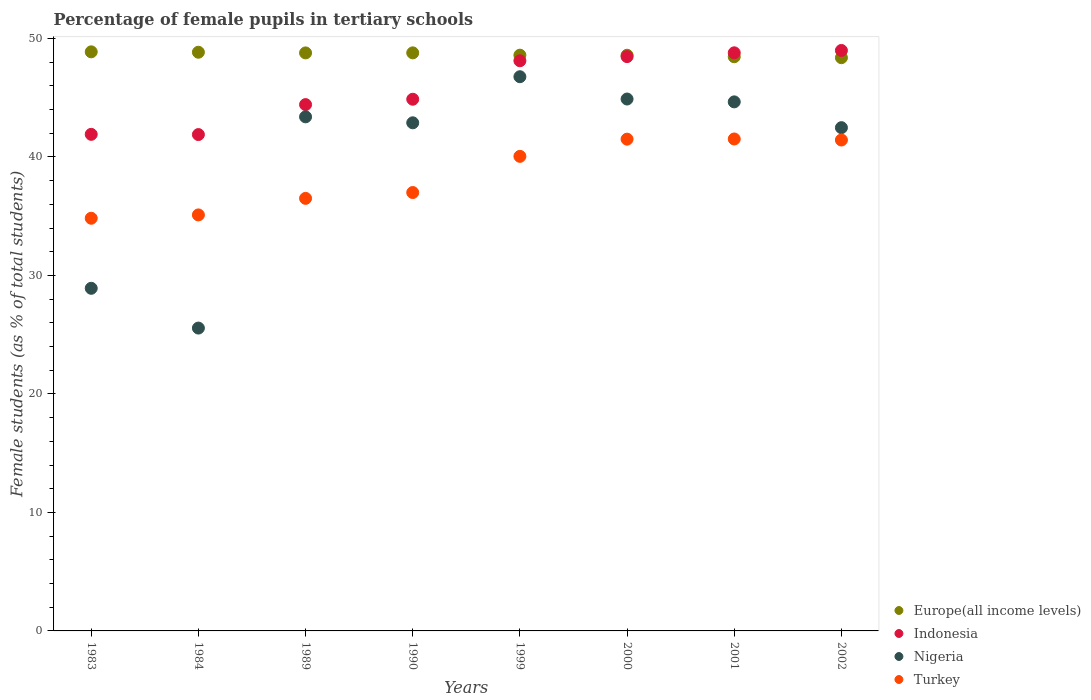How many different coloured dotlines are there?
Your answer should be compact. 4. Is the number of dotlines equal to the number of legend labels?
Ensure brevity in your answer.  Yes. What is the percentage of female pupils in tertiary schools in Turkey in 2001?
Provide a short and direct response. 41.51. Across all years, what is the maximum percentage of female pupils in tertiary schools in Turkey?
Make the answer very short. 41.51. Across all years, what is the minimum percentage of female pupils in tertiary schools in Nigeria?
Provide a short and direct response. 25.56. In which year was the percentage of female pupils in tertiary schools in Nigeria maximum?
Your answer should be very brief. 1999. What is the total percentage of female pupils in tertiary schools in Europe(all income levels) in the graph?
Provide a short and direct response. 389.24. What is the difference between the percentage of female pupils in tertiary schools in Turkey in 1984 and that in 1999?
Offer a very short reply. -4.94. What is the difference between the percentage of female pupils in tertiary schools in Europe(all income levels) in 1984 and the percentage of female pupils in tertiary schools in Turkey in 2000?
Provide a succinct answer. 7.33. What is the average percentage of female pupils in tertiary schools in Turkey per year?
Provide a succinct answer. 38.49. In the year 1999, what is the difference between the percentage of female pupils in tertiary schools in Indonesia and percentage of female pupils in tertiary schools in Turkey?
Offer a very short reply. 8.07. What is the ratio of the percentage of female pupils in tertiary schools in Turkey in 1984 to that in 2001?
Offer a very short reply. 0.85. What is the difference between the highest and the second highest percentage of female pupils in tertiary schools in Europe(all income levels)?
Your response must be concise. 0.03. What is the difference between the highest and the lowest percentage of female pupils in tertiary schools in Europe(all income levels)?
Give a very brief answer. 0.49. In how many years, is the percentage of female pupils in tertiary schools in Europe(all income levels) greater than the average percentage of female pupils in tertiary schools in Europe(all income levels) taken over all years?
Offer a very short reply. 4. Is it the case that in every year, the sum of the percentage of female pupils in tertiary schools in Turkey and percentage of female pupils in tertiary schools in Indonesia  is greater than the percentage of female pupils in tertiary schools in Nigeria?
Give a very brief answer. Yes. Does the percentage of female pupils in tertiary schools in Nigeria monotonically increase over the years?
Your answer should be very brief. No. Is the percentage of female pupils in tertiary schools in Nigeria strictly greater than the percentage of female pupils in tertiary schools in Europe(all income levels) over the years?
Provide a short and direct response. No. Is the percentage of female pupils in tertiary schools in Europe(all income levels) strictly less than the percentage of female pupils in tertiary schools in Nigeria over the years?
Provide a succinct answer. No. How many dotlines are there?
Your answer should be very brief. 4. Are the values on the major ticks of Y-axis written in scientific E-notation?
Make the answer very short. No. Does the graph contain grids?
Your response must be concise. No. How many legend labels are there?
Make the answer very short. 4. What is the title of the graph?
Keep it short and to the point. Percentage of female pupils in tertiary schools. Does "United Kingdom" appear as one of the legend labels in the graph?
Your response must be concise. No. What is the label or title of the X-axis?
Ensure brevity in your answer.  Years. What is the label or title of the Y-axis?
Provide a succinct answer. Female students (as % of total students). What is the Female students (as % of total students) in Europe(all income levels) in 1983?
Offer a terse response. 48.87. What is the Female students (as % of total students) in Indonesia in 1983?
Offer a very short reply. 41.9. What is the Female students (as % of total students) in Nigeria in 1983?
Offer a terse response. 28.91. What is the Female students (as % of total students) of Turkey in 1983?
Keep it short and to the point. 34.82. What is the Female students (as % of total students) of Europe(all income levels) in 1984?
Provide a short and direct response. 48.83. What is the Female students (as % of total students) in Indonesia in 1984?
Keep it short and to the point. 41.88. What is the Female students (as % of total students) of Nigeria in 1984?
Your response must be concise. 25.56. What is the Female students (as % of total students) in Turkey in 1984?
Provide a short and direct response. 35.1. What is the Female students (as % of total students) of Europe(all income levels) in 1989?
Provide a succinct answer. 48.78. What is the Female students (as % of total students) of Indonesia in 1989?
Provide a short and direct response. 44.41. What is the Female students (as % of total students) in Nigeria in 1989?
Keep it short and to the point. 43.38. What is the Female students (as % of total students) of Turkey in 1989?
Keep it short and to the point. 36.5. What is the Female students (as % of total students) of Europe(all income levels) in 1990?
Make the answer very short. 48.78. What is the Female students (as % of total students) in Indonesia in 1990?
Provide a succinct answer. 44.87. What is the Female students (as % of total students) of Nigeria in 1990?
Ensure brevity in your answer.  42.88. What is the Female students (as % of total students) in Turkey in 1990?
Offer a terse response. 36.99. What is the Female students (as % of total students) in Europe(all income levels) in 1999?
Give a very brief answer. 48.59. What is the Female students (as % of total students) in Indonesia in 1999?
Provide a succinct answer. 48.11. What is the Female students (as % of total students) in Nigeria in 1999?
Your response must be concise. 46.77. What is the Female students (as % of total students) of Turkey in 1999?
Your response must be concise. 40.05. What is the Female students (as % of total students) of Europe(all income levels) in 2000?
Keep it short and to the point. 48.58. What is the Female students (as % of total students) of Indonesia in 2000?
Your answer should be very brief. 48.46. What is the Female students (as % of total students) in Nigeria in 2000?
Provide a short and direct response. 44.88. What is the Female students (as % of total students) in Turkey in 2000?
Your answer should be very brief. 41.5. What is the Female students (as % of total students) in Europe(all income levels) in 2001?
Provide a short and direct response. 48.45. What is the Female students (as % of total students) of Indonesia in 2001?
Your answer should be compact. 48.78. What is the Female students (as % of total students) of Nigeria in 2001?
Your response must be concise. 44.64. What is the Female students (as % of total students) in Turkey in 2001?
Ensure brevity in your answer.  41.51. What is the Female students (as % of total students) in Europe(all income levels) in 2002?
Offer a very short reply. 48.37. What is the Female students (as % of total students) in Indonesia in 2002?
Provide a short and direct response. 48.98. What is the Female students (as % of total students) in Nigeria in 2002?
Offer a terse response. 42.47. What is the Female students (as % of total students) of Turkey in 2002?
Your response must be concise. 41.42. Across all years, what is the maximum Female students (as % of total students) in Europe(all income levels)?
Keep it short and to the point. 48.87. Across all years, what is the maximum Female students (as % of total students) in Indonesia?
Make the answer very short. 48.98. Across all years, what is the maximum Female students (as % of total students) in Nigeria?
Ensure brevity in your answer.  46.77. Across all years, what is the maximum Female students (as % of total students) of Turkey?
Provide a short and direct response. 41.51. Across all years, what is the minimum Female students (as % of total students) in Europe(all income levels)?
Offer a terse response. 48.37. Across all years, what is the minimum Female students (as % of total students) in Indonesia?
Provide a short and direct response. 41.88. Across all years, what is the minimum Female students (as % of total students) in Nigeria?
Your response must be concise. 25.56. Across all years, what is the minimum Female students (as % of total students) in Turkey?
Offer a terse response. 34.82. What is the total Female students (as % of total students) of Europe(all income levels) in the graph?
Give a very brief answer. 389.24. What is the total Female students (as % of total students) in Indonesia in the graph?
Your answer should be very brief. 367.41. What is the total Female students (as % of total students) of Nigeria in the graph?
Offer a terse response. 319.49. What is the total Female students (as % of total students) in Turkey in the graph?
Offer a terse response. 307.9. What is the difference between the Female students (as % of total students) in Europe(all income levels) in 1983 and that in 1984?
Offer a very short reply. 0.03. What is the difference between the Female students (as % of total students) of Indonesia in 1983 and that in 1984?
Provide a succinct answer. 0.02. What is the difference between the Female students (as % of total students) of Nigeria in 1983 and that in 1984?
Provide a succinct answer. 3.36. What is the difference between the Female students (as % of total students) of Turkey in 1983 and that in 1984?
Your answer should be very brief. -0.28. What is the difference between the Female students (as % of total students) in Europe(all income levels) in 1983 and that in 1989?
Your answer should be very brief. 0.09. What is the difference between the Female students (as % of total students) of Indonesia in 1983 and that in 1989?
Give a very brief answer. -2.51. What is the difference between the Female students (as % of total students) of Nigeria in 1983 and that in 1989?
Provide a succinct answer. -14.47. What is the difference between the Female students (as % of total students) of Turkey in 1983 and that in 1989?
Your answer should be compact. -1.68. What is the difference between the Female students (as % of total students) of Europe(all income levels) in 1983 and that in 1990?
Offer a terse response. 0.09. What is the difference between the Female students (as % of total students) of Indonesia in 1983 and that in 1990?
Give a very brief answer. -2.96. What is the difference between the Female students (as % of total students) in Nigeria in 1983 and that in 1990?
Offer a very short reply. -13.97. What is the difference between the Female students (as % of total students) of Turkey in 1983 and that in 1990?
Keep it short and to the point. -2.17. What is the difference between the Female students (as % of total students) of Europe(all income levels) in 1983 and that in 1999?
Offer a terse response. 0.28. What is the difference between the Female students (as % of total students) of Indonesia in 1983 and that in 1999?
Give a very brief answer. -6.21. What is the difference between the Female students (as % of total students) of Nigeria in 1983 and that in 1999?
Your answer should be compact. -17.85. What is the difference between the Female students (as % of total students) of Turkey in 1983 and that in 1999?
Make the answer very short. -5.22. What is the difference between the Female students (as % of total students) of Europe(all income levels) in 1983 and that in 2000?
Your answer should be compact. 0.29. What is the difference between the Female students (as % of total students) of Indonesia in 1983 and that in 2000?
Give a very brief answer. -6.56. What is the difference between the Female students (as % of total students) in Nigeria in 1983 and that in 2000?
Your answer should be compact. -15.97. What is the difference between the Female students (as % of total students) of Turkey in 1983 and that in 2000?
Your answer should be compact. -6.67. What is the difference between the Female students (as % of total students) in Europe(all income levels) in 1983 and that in 2001?
Your answer should be compact. 0.41. What is the difference between the Female students (as % of total students) of Indonesia in 1983 and that in 2001?
Your answer should be compact. -6.88. What is the difference between the Female students (as % of total students) of Nigeria in 1983 and that in 2001?
Your response must be concise. -15.73. What is the difference between the Female students (as % of total students) of Turkey in 1983 and that in 2001?
Give a very brief answer. -6.69. What is the difference between the Female students (as % of total students) in Europe(all income levels) in 1983 and that in 2002?
Your answer should be very brief. 0.49. What is the difference between the Female students (as % of total students) in Indonesia in 1983 and that in 2002?
Keep it short and to the point. -7.08. What is the difference between the Female students (as % of total students) of Nigeria in 1983 and that in 2002?
Your answer should be compact. -13.56. What is the difference between the Female students (as % of total students) in Turkey in 1983 and that in 2002?
Your answer should be very brief. -6.6. What is the difference between the Female students (as % of total students) in Europe(all income levels) in 1984 and that in 1989?
Give a very brief answer. 0.06. What is the difference between the Female students (as % of total students) of Indonesia in 1984 and that in 1989?
Make the answer very short. -2.53. What is the difference between the Female students (as % of total students) of Nigeria in 1984 and that in 1989?
Provide a succinct answer. -17.83. What is the difference between the Female students (as % of total students) in Turkey in 1984 and that in 1989?
Make the answer very short. -1.4. What is the difference between the Female students (as % of total students) in Europe(all income levels) in 1984 and that in 1990?
Keep it short and to the point. 0.05. What is the difference between the Female students (as % of total students) of Indonesia in 1984 and that in 1990?
Your response must be concise. -2.98. What is the difference between the Female students (as % of total students) in Nigeria in 1984 and that in 1990?
Your answer should be very brief. -17.32. What is the difference between the Female students (as % of total students) of Turkey in 1984 and that in 1990?
Your answer should be compact. -1.89. What is the difference between the Female students (as % of total students) in Europe(all income levels) in 1984 and that in 1999?
Make the answer very short. 0.25. What is the difference between the Female students (as % of total students) in Indonesia in 1984 and that in 1999?
Ensure brevity in your answer.  -6.23. What is the difference between the Female students (as % of total students) in Nigeria in 1984 and that in 1999?
Offer a very short reply. -21.21. What is the difference between the Female students (as % of total students) in Turkey in 1984 and that in 1999?
Offer a very short reply. -4.94. What is the difference between the Female students (as % of total students) of Europe(all income levels) in 1984 and that in 2000?
Make the answer very short. 0.25. What is the difference between the Female students (as % of total students) of Indonesia in 1984 and that in 2000?
Your answer should be very brief. -6.58. What is the difference between the Female students (as % of total students) of Nigeria in 1984 and that in 2000?
Your response must be concise. -19.33. What is the difference between the Female students (as % of total students) in Turkey in 1984 and that in 2000?
Your response must be concise. -6.39. What is the difference between the Female students (as % of total students) in Europe(all income levels) in 1984 and that in 2001?
Offer a very short reply. 0.38. What is the difference between the Female students (as % of total students) in Indonesia in 1984 and that in 2001?
Provide a succinct answer. -6.9. What is the difference between the Female students (as % of total students) of Nigeria in 1984 and that in 2001?
Ensure brevity in your answer.  -19.09. What is the difference between the Female students (as % of total students) of Turkey in 1984 and that in 2001?
Your response must be concise. -6.41. What is the difference between the Female students (as % of total students) of Europe(all income levels) in 1984 and that in 2002?
Your answer should be compact. 0.46. What is the difference between the Female students (as % of total students) in Indonesia in 1984 and that in 2002?
Ensure brevity in your answer.  -7.1. What is the difference between the Female students (as % of total students) of Nigeria in 1984 and that in 2002?
Your answer should be compact. -16.91. What is the difference between the Female students (as % of total students) of Turkey in 1984 and that in 2002?
Offer a very short reply. -6.32. What is the difference between the Female students (as % of total students) of Europe(all income levels) in 1989 and that in 1990?
Your answer should be very brief. -0. What is the difference between the Female students (as % of total students) of Indonesia in 1989 and that in 1990?
Provide a short and direct response. -0.45. What is the difference between the Female students (as % of total students) of Nigeria in 1989 and that in 1990?
Provide a short and direct response. 0.5. What is the difference between the Female students (as % of total students) of Turkey in 1989 and that in 1990?
Offer a terse response. -0.49. What is the difference between the Female students (as % of total students) in Europe(all income levels) in 1989 and that in 1999?
Your response must be concise. 0.19. What is the difference between the Female students (as % of total students) of Indonesia in 1989 and that in 1999?
Keep it short and to the point. -3.7. What is the difference between the Female students (as % of total students) of Nigeria in 1989 and that in 1999?
Keep it short and to the point. -3.38. What is the difference between the Female students (as % of total students) of Turkey in 1989 and that in 1999?
Your answer should be very brief. -3.55. What is the difference between the Female students (as % of total students) in Europe(all income levels) in 1989 and that in 2000?
Ensure brevity in your answer.  0.2. What is the difference between the Female students (as % of total students) in Indonesia in 1989 and that in 2000?
Offer a terse response. -4.05. What is the difference between the Female students (as % of total students) of Nigeria in 1989 and that in 2000?
Provide a short and direct response. -1.5. What is the difference between the Female students (as % of total students) in Turkey in 1989 and that in 2000?
Keep it short and to the point. -5. What is the difference between the Female students (as % of total students) in Europe(all income levels) in 1989 and that in 2001?
Offer a very short reply. 0.32. What is the difference between the Female students (as % of total students) of Indonesia in 1989 and that in 2001?
Provide a succinct answer. -4.37. What is the difference between the Female students (as % of total students) in Nigeria in 1989 and that in 2001?
Ensure brevity in your answer.  -1.26. What is the difference between the Female students (as % of total students) in Turkey in 1989 and that in 2001?
Make the answer very short. -5.01. What is the difference between the Female students (as % of total students) of Europe(all income levels) in 1989 and that in 2002?
Ensure brevity in your answer.  0.4. What is the difference between the Female students (as % of total students) of Indonesia in 1989 and that in 2002?
Ensure brevity in your answer.  -4.57. What is the difference between the Female students (as % of total students) in Nigeria in 1989 and that in 2002?
Give a very brief answer. 0.91. What is the difference between the Female students (as % of total students) of Turkey in 1989 and that in 2002?
Give a very brief answer. -4.92. What is the difference between the Female students (as % of total students) in Europe(all income levels) in 1990 and that in 1999?
Offer a terse response. 0.19. What is the difference between the Female students (as % of total students) in Indonesia in 1990 and that in 1999?
Give a very brief answer. -3.25. What is the difference between the Female students (as % of total students) of Nigeria in 1990 and that in 1999?
Provide a short and direct response. -3.89. What is the difference between the Female students (as % of total students) in Turkey in 1990 and that in 1999?
Your answer should be very brief. -3.05. What is the difference between the Female students (as % of total students) in Europe(all income levels) in 1990 and that in 2000?
Provide a succinct answer. 0.2. What is the difference between the Female students (as % of total students) of Indonesia in 1990 and that in 2000?
Ensure brevity in your answer.  -3.6. What is the difference between the Female students (as % of total students) in Nigeria in 1990 and that in 2000?
Provide a short and direct response. -2.01. What is the difference between the Female students (as % of total students) of Turkey in 1990 and that in 2000?
Your answer should be compact. -4.5. What is the difference between the Female students (as % of total students) of Europe(all income levels) in 1990 and that in 2001?
Ensure brevity in your answer.  0.33. What is the difference between the Female students (as % of total students) in Indonesia in 1990 and that in 2001?
Offer a very short reply. -3.92. What is the difference between the Female students (as % of total students) in Nigeria in 1990 and that in 2001?
Your response must be concise. -1.77. What is the difference between the Female students (as % of total students) in Turkey in 1990 and that in 2001?
Your answer should be compact. -4.52. What is the difference between the Female students (as % of total students) in Europe(all income levels) in 1990 and that in 2002?
Your answer should be compact. 0.41. What is the difference between the Female students (as % of total students) in Indonesia in 1990 and that in 2002?
Keep it short and to the point. -4.12. What is the difference between the Female students (as % of total students) in Nigeria in 1990 and that in 2002?
Provide a succinct answer. 0.41. What is the difference between the Female students (as % of total students) in Turkey in 1990 and that in 2002?
Offer a terse response. -4.43. What is the difference between the Female students (as % of total students) of Europe(all income levels) in 1999 and that in 2000?
Ensure brevity in your answer.  0.01. What is the difference between the Female students (as % of total students) of Indonesia in 1999 and that in 2000?
Offer a terse response. -0.35. What is the difference between the Female students (as % of total students) in Nigeria in 1999 and that in 2000?
Keep it short and to the point. 1.88. What is the difference between the Female students (as % of total students) of Turkey in 1999 and that in 2000?
Ensure brevity in your answer.  -1.45. What is the difference between the Female students (as % of total students) in Europe(all income levels) in 1999 and that in 2001?
Provide a short and direct response. 0.13. What is the difference between the Female students (as % of total students) in Indonesia in 1999 and that in 2001?
Offer a terse response. -0.67. What is the difference between the Female students (as % of total students) of Nigeria in 1999 and that in 2001?
Your answer should be very brief. 2.12. What is the difference between the Female students (as % of total students) in Turkey in 1999 and that in 2001?
Offer a terse response. -1.47. What is the difference between the Female students (as % of total students) of Europe(all income levels) in 1999 and that in 2002?
Keep it short and to the point. 0.21. What is the difference between the Female students (as % of total students) of Indonesia in 1999 and that in 2002?
Give a very brief answer. -0.87. What is the difference between the Female students (as % of total students) of Nigeria in 1999 and that in 2002?
Offer a very short reply. 4.3. What is the difference between the Female students (as % of total students) of Turkey in 1999 and that in 2002?
Ensure brevity in your answer.  -1.38. What is the difference between the Female students (as % of total students) of Europe(all income levels) in 2000 and that in 2001?
Provide a short and direct response. 0.13. What is the difference between the Female students (as % of total students) of Indonesia in 2000 and that in 2001?
Keep it short and to the point. -0.32. What is the difference between the Female students (as % of total students) in Nigeria in 2000 and that in 2001?
Give a very brief answer. 0.24. What is the difference between the Female students (as % of total students) of Turkey in 2000 and that in 2001?
Provide a short and direct response. -0.02. What is the difference between the Female students (as % of total students) in Europe(all income levels) in 2000 and that in 2002?
Ensure brevity in your answer.  0.21. What is the difference between the Female students (as % of total students) of Indonesia in 2000 and that in 2002?
Provide a succinct answer. -0.52. What is the difference between the Female students (as % of total students) of Nigeria in 2000 and that in 2002?
Make the answer very short. 2.42. What is the difference between the Female students (as % of total students) of Turkey in 2000 and that in 2002?
Make the answer very short. 0.07. What is the difference between the Female students (as % of total students) of Europe(all income levels) in 2001 and that in 2002?
Keep it short and to the point. 0.08. What is the difference between the Female students (as % of total students) of Indonesia in 2001 and that in 2002?
Provide a succinct answer. -0.2. What is the difference between the Female students (as % of total students) in Nigeria in 2001 and that in 2002?
Ensure brevity in your answer.  2.18. What is the difference between the Female students (as % of total students) in Turkey in 2001 and that in 2002?
Your answer should be very brief. 0.09. What is the difference between the Female students (as % of total students) of Europe(all income levels) in 1983 and the Female students (as % of total students) of Indonesia in 1984?
Make the answer very short. 6.98. What is the difference between the Female students (as % of total students) of Europe(all income levels) in 1983 and the Female students (as % of total students) of Nigeria in 1984?
Your response must be concise. 23.31. What is the difference between the Female students (as % of total students) of Europe(all income levels) in 1983 and the Female students (as % of total students) of Turkey in 1984?
Your response must be concise. 13.76. What is the difference between the Female students (as % of total students) in Indonesia in 1983 and the Female students (as % of total students) in Nigeria in 1984?
Give a very brief answer. 16.35. What is the difference between the Female students (as % of total students) in Indonesia in 1983 and the Female students (as % of total students) in Turkey in 1984?
Keep it short and to the point. 6.8. What is the difference between the Female students (as % of total students) in Nigeria in 1983 and the Female students (as % of total students) in Turkey in 1984?
Your answer should be compact. -6.19. What is the difference between the Female students (as % of total students) in Europe(all income levels) in 1983 and the Female students (as % of total students) in Indonesia in 1989?
Your answer should be very brief. 4.45. What is the difference between the Female students (as % of total students) of Europe(all income levels) in 1983 and the Female students (as % of total students) of Nigeria in 1989?
Your response must be concise. 5.48. What is the difference between the Female students (as % of total students) in Europe(all income levels) in 1983 and the Female students (as % of total students) in Turkey in 1989?
Provide a succinct answer. 12.37. What is the difference between the Female students (as % of total students) of Indonesia in 1983 and the Female students (as % of total students) of Nigeria in 1989?
Keep it short and to the point. -1.48. What is the difference between the Female students (as % of total students) of Indonesia in 1983 and the Female students (as % of total students) of Turkey in 1989?
Give a very brief answer. 5.4. What is the difference between the Female students (as % of total students) of Nigeria in 1983 and the Female students (as % of total students) of Turkey in 1989?
Keep it short and to the point. -7.59. What is the difference between the Female students (as % of total students) in Europe(all income levels) in 1983 and the Female students (as % of total students) in Indonesia in 1990?
Give a very brief answer. 4. What is the difference between the Female students (as % of total students) in Europe(all income levels) in 1983 and the Female students (as % of total students) in Nigeria in 1990?
Offer a terse response. 5.99. What is the difference between the Female students (as % of total students) of Europe(all income levels) in 1983 and the Female students (as % of total students) of Turkey in 1990?
Provide a short and direct response. 11.87. What is the difference between the Female students (as % of total students) in Indonesia in 1983 and the Female students (as % of total students) in Nigeria in 1990?
Offer a terse response. -0.97. What is the difference between the Female students (as % of total students) of Indonesia in 1983 and the Female students (as % of total students) of Turkey in 1990?
Provide a succinct answer. 4.91. What is the difference between the Female students (as % of total students) of Nigeria in 1983 and the Female students (as % of total students) of Turkey in 1990?
Keep it short and to the point. -8.08. What is the difference between the Female students (as % of total students) of Europe(all income levels) in 1983 and the Female students (as % of total students) of Indonesia in 1999?
Provide a short and direct response. 0.75. What is the difference between the Female students (as % of total students) in Europe(all income levels) in 1983 and the Female students (as % of total students) in Nigeria in 1999?
Provide a succinct answer. 2.1. What is the difference between the Female students (as % of total students) in Europe(all income levels) in 1983 and the Female students (as % of total students) in Turkey in 1999?
Offer a very short reply. 8.82. What is the difference between the Female students (as % of total students) of Indonesia in 1983 and the Female students (as % of total students) of Nigeria in 1999?
Ensure brevity in your answer.  -4.86. What is the difference between the Female students (as % of total students) of Indonesia in 1983 and the Female students (as % of total students) of Turkey in 1999?
Offer a very short reply. 1.86. What is the difference between the Female students (as % of total students) of Nigeria in 1983 and the Female students (as % of total students) of Turkey in 1999?
Make the answer very short. -11.13. What is the difference between the Female students (as % of total students) in Europe(all income levels) in 1983 and the Female students (as % of total students) in Indonesia in 2000?
Provide a short and direct response. 0.4. What is the difference between the Female students (as % of total students) of Europe(all income levels) in 1983 and the Female students (as % of total students) of Nigeria in 2000?
Offer a very short reply. 3.98. What is the difference between the Female students (as % of total students) of Europe(all income levels) in 1983 and the Female students (as % of total students) of Turkey in 2000?
Offer a terse response. 7.37. What is the difference between the Female students (as % of total students) in Indonesia in 1983 and the Female students (as % of total students) in Nigeria in 2000?
Ensure brevity in your answer.  -2.98. What is the difference between the Female students (as % of total students) of Indonesia in 1983 and the Female students (as % of total students) of Turkey in 2000?
Your response must be concise. 0.41. What is the difference between the Female students (as % of total students) in Nigeria in 1983 and the Female students (as % of total students) in Turkey in 2000?
Your response must be concise. -12.59. What is the difference between the Female students (as % of total students) of Europe(all income levels) in 1983 and the Female students (as % of total students) of Indonesia in 2001?
Offer a terse response. 0.08. What is the difference between the Female students (as % of total students) in Europe(all income levels) in 1983 and the Female students (as % of total students) in Nigeria in 2001?
Ensure brevity in your answer.  4.22. What is the difference between the Female students (as % of total students) in Europe(all income levels) in 1983 and the Female students (as % of total students) in Turkey in 2001?
Offer a very short reply. 7.35. What is the difference between the Female students (as % of total students) in Indonesia in 1983 and the Female students (as % of total students) in Nigeria in 2001?
Your answer should be compact. -2.74. What is the difference between the Female students (as % of total students) of Indonesia in 1983 and the Female students (as % of total students) of Turkey in 2001?
Keep it short and to the point. 0.39. What is the difference between the Female students (as % of total students) in Nigeria in 1983 and the Female students (as % of total students) in Turkey in 2001?
Offer a very short reply. -12.6. What is the difference between the Female students (as % of total students) of Europe(all income levels) in 1983 and the Female students (as % of total students) of Indonesia in 2002?
Ensure brevity in your answer.  -0.12. What is the difference between the Female students (as % of total students) of Europe(all income levels) in 1983 and the Female students (as % of total students) of Nigeria in 2002?
Ensure brevity in your answer.  6.4. What is the difference between the Female students (as % of total students) of Europe(all income levels) in 1983 and the Female students (as % of total students) of Turkey in 2002?
Ensure brevity in your answer.  7.44. What is the difference between the Female students (as % of total students) of Indonesia in 1983 and the Female students (as % of total students) of Nigeria in 2002?
Keep it short and to the point. -0.56. What is the difference between the Female students (as % of total students) of Indonesia in 1983 and the Female students (as % of total students) of Turkey in 2002?
Provide a short and direct response. 0.48. What is the difference between the Female students (as % of total students) in Nigeria in 1983 and the Female students (as % of total students) in Turkey in 2002?
Give a very brief answer. -12.51. What is the difference between the Female students (as % of total students) in Europe(all income levels) in 1984 and the Female students (as % of total students) in Indonesia in 1989?
Ensure brevity in your answer.  4.42. What is the difference between the Female students (as % of total students) in Europe(all income levels) in 1984 and the Female students (as % of total students) in Nigeria in 1989?
Your answer should be compact. 5.45. What is the difference between the Female students (as % of total students) in Europe(all income levels) in 1984 and the Female students (as % of total students) in Turkey in 1989?
Give a very brief answer. 12.33. What is the difference between the Female students (as % of total students) in Indonesia in 1984 and the Female students (as % of total students) in Nigeria in 1989?
Give a very brief answer. -1.5. What is the difference between the Female students (as % of total students) in Indonesia in 1984 and the Female students (as % of total students) in Turkey in 1989?
Offer a very short reply. 5.38. What is the difference between the Female students (as % of total students) of Nigeria in 1984 and the Female students (as % of total students) of Turkey in 1989?
Offer a terse response. -10.95. What is the difference between the Female students (as % of total students) in Europe(all income levels) in 1984 and the Female students (as % of total students) in Indonesia in 1990?
Your answer should be compact. 3.97. What is the difference between the Female students (as % of total students) of Europe(all income levels) in 1984 and the Female students (as % of total students) of Nigeria in 1990?
Your answer should be compact. 5.95. What is the difference between the Female students (as % of total students) in Europe(all income levels) in 1984 and the Female students (as % of total students) in Turkey in 1990?
Make the answer very short. 11.84. What is the difference between the Female students (as % of total students) of Indonesia in 1984 and the Female students (as % of total students) of Nigeria in 1990?
Provide a succinct answer. -0.99. What is the difference between the Female students (as % of total students) of Indonesia in 1984 and the Female students (as % of total students) of Turkey in 1990?
Provide a succinct answer. 4.89. What is the difference between the Female students (as % of total students) in Nigeria in 1984 and the Female students (as % of total students) in Turkey in 1990?
Offer a terse response. -11.44. What is the difference between the Female students (as % of total students) of Europe(all income levels) in 1984 and the Female students (as % of total students) of Indonesia in 1999?
Keep it short and to the point. 0.72. What is the difference between the Female students (as % of total students) in Europe(all income levels) in 1984 and the Female students (as % of total students) in Nigeria in 1999?
Provide a succinct answer. 2.07. What is the difference between the Female students (as % of total students) of Europe(all income levels) in 1984 and the Female students (as % of total students) of Turkey in 1999?
Offer a terse response. 8.79. What is the difference between the Female students (as % of total students) of Indonesia in 1984 and the Female students (as % of total students) of Nigeria in 1999?
Your response must be concise. -4.88. What is the difference between the Female students (as % of total students) in Indonesia in 1984 and the Female students (as % of total students) in Turkey in 1999?
Ensure brevity in your answer.  1.84. What is the difference between the Female students (as % of total students) in Nigeria in 1984 and the Female students (as % of total students) in Turkey in 1999?
Your answer should be very brief. -14.49. What is the difference between the Female students (as % of total students) of Europe(all income levels) in 1984 and the Female students (as % of total students) of Indonesia in 2000?
Keep it short and to the point. 0.37. What is the difference between the Female students (as % of total students) in Europe(all income levels) in 1984 and the Female students (as % of total students) in Nigeria in 2000?
Your answer should be very brief. 3.95. What is the difference between the Female students (as % of total students) in Europe(all income levels) in 1984 and the Female students (as % of total students) in Turkey in 2000?
Your answer should be very brief. 7.33. What is the difference between the Female students (as % of total students) in Indonesia in 1984 and the Female students (as % of total students) in Nigeria in 2000?
Provide a short and direct response. -3. What is the difference between the Female students (as % of total students) in Indonesia in 1984 and the Female students (as % of total students) in Turkey in 2000?
Your response must be concise. 0.39. What is the difference between the Female students (as % of total students) in Nigeria in 1984 and the Female students (as % of total students) in Turkey in 2000?
Your answer should be very brief. -15.94. What is the difference between the Female students (as % of total students) of Europe(all income levels) in 1984 and the Female students (as % of total students) of Indonesia in 2001?
Your response must be concise. 0.05. What is the difference between the Female students (as % of total students) of Europe(all income levels) in 1984 and the Female students (as % of total students) of Nigeria in 2001?
Keep it short and to the point. 4.19. What is the difference between the Female students (as % of total students) in Europe(all income levels) in 1984 and the Female students (as % of total students) in Turkey in 2001?
Give a very brief answer. 7.32. What is the difference between the Female students (as % of total students) of Indonesia in 1984 and the Female students (as % of total students) of Nigeria in 2001?
Provide a succinct answer. -2.76. What is the difference between the Female students (as % of total students) in Indonesia in 1984 and the Female students (as % of total students) in Turkey in 2001?
Your answer should be compact. 0.37. What is the difference between the Female students (as % of total students) of Nigeria in 1984 and the Female students (as % of total students) of Turkey in 2001?
Ensure brevity in your answer.  -15.96. What is the difference between the Female students (as % of total students) of Europe(all income levels) in 1984 and the Female students (as % of total students) of Indonesia in 2002?
Your response must be concise. -0.15. What is the difference between the Female students (as % of total students) of Europe(all income levels) in 1984 and the Female students (as % of total students) of Nigeria in 2002?
Keep it short and to the point. 6.37. What is the difference between the Female students (as % of total students) of Europe(all income levels) in 1984 and the Female students (as % of total students) of Turkey in 2002?
Offer a terse response. 7.41. What is the difference between the Female students (as % of total students) of Indonesia in 1984 and the Female students (as % of total students) of Nigeria in 2002?
Give a very brief answer. -0.58. What is the difference between the Female students (as % of total students) in Indonesia in 1984 and the Female students (as % of total students) in Turkey in 2002?
Your response must be concise. 0.46. What is the difference between the Female students (as % of total students) in Nigeria in 1984 and the Female students (as % of total students) in Turkey in 2002?
Your response must be concise. -15.87. What is the difference between the Female students (as % of total students) of Europe(all income levels) in 1989 and the Female students (as % of total students) of Indonesia in 1990?
Your answer should be compact. 3.91. What is the difference between the Female students (as % of total students) of Europe(all income levels) in 1989 and the Female students (as % of total students) of Nigeria in 1990?
Your answer should be very brief. 5.9. What is the difference between the Female students (as % of total students) of Europe(all income levels) in 1989 and the Female students (as % of total students) of Turkey in 1990?
Give a very brief answer. 11.78. What is the difference between the Female students (as % of total students) of Indonesia in 1989 and the Female students (as % of total students) of Nigeria in 1990?
Offer a terse response. 1.54. What is the difference between the Female students (as % of total students) of Indonesia in 1989 and the Female students (as % of total students) of Turkey in 1990?
Ensure brevity in your answer.  7.42. What is the difference between the Female students (as % of total students) of Nigeria in 1989 and the Female students (as % of total students) of Turkey in 1990?
Give a very brief answer. 6.39. What is the difference between the Female students (as % of total students) in Europe(all income levels) in 1989 and the Female students (as % of total students) in Indonesia in 1999?
Your answer should be very brief. 0.66. What is the difference between the Female students (as % of total students) of Europe(all income levels) in 1989 and the Female students (as % of total students) of Nigeria in 1999?
Keep it short and to the point. 2.01. What is the difference between the Female students (as % of total students) of Europe(all income levels) in 1989 and the Female students (as % of total students) of Turkey in 1999?
Your answer should be very brief. 8.73. What is the difference between the Female students (as % of total students) in Indonesia in 1989 and the Female students (as % of total students) in Nigeria in 1999?
Offer a very short reply. -2.35. What is the difference between the Female students (as % of total students) in Indonesia in 1989 and the Female students (as % of total students) in Turkey in 1999?
Your response must be concise. 4.37. What is the difference between the Female students (as % of total students) in Nigeria in 1989 and the Female students (as % of total students) in Turkey in 1999?
Provide a short and direct response. 3.33. What is the difference between the Female students (as % of total students) of Europe(all income levels) in 1989 and the Female students (as % of total students) of Indonesia in 2000?
Your answer should be very brief. 0.31. What is the difference between the Female students (as % of total students) of Europe(all income levels) in 1989 and the Female students (as % of total students) of Nigeria in 2000?
Provide a succinct answer. 3.89. What is the difference between the Female students (as % of total students) in Europe(all income levels) in 1989 and the Female students (as % of total students) in Turkey in 2000?
Make the answer very short. 7.28. What is the difference between the Female students (as % of total students) of Indonesia in 1989 and the Female students (as % of total students) of Nigeria in 2000?
Provide a short and direct response. -0.47. What is the difference between the Female students (as % of total students) of Indonesia in 1989 and the Female students (as % of total students) of Turkey in 2000?
Give a very brief answer. 2.92. What is the difference between the Female students (as % of total students) of Nigeria in 1989 and the Female students (as % of total students) of Turkey in 2000?
Your answer should be compact. 1.88. What is the difference between the Female students (as % of total students) in Europe(all income levels) in 1989 and the Female students (as % of total students) in Indonesia in 2001?
Offer a terse response. -0.01. What is the difference between the Female students (as % of total students) in Europe(all income levels) in 1989 and the Female students (as % of total students) in Nigeria in 2001?
Offer a terse response. 4.13. What is the difference between the Female students (as % of total students) in Europe(all income levels) in 1989 and the Female students (as % of total students) in Turkey in 2001?
Your response must be concise. 7.26. What is the difference between the Female students (as % of total students) in Indonesia in 1989 and the Female students (as % of total students) in Nigeria in 2001?
Your response must be concise. -0.23. What is the difference between the Female students (as % of total students) in Indonesia in 1989 and the Female students (as % of total students) in Turkey in 2001?
Provide a short and direct response. 2.9. What is the difference between the Female students (as % of total students) of Nigeria in 1989 and the Female students (as % of total students) of Turkey in 2001?
Provide a short and direct response. 1.87. What is the difference between the Female students (as % of total students) of Europe(all income levels) in 1989 and the Female students (as % of total students) of Indonesia in 2002?
Provide a succinct answer. -0.21. What is the difference between the Female students (as % of total students) of Europe(all income levels) in 1989 and the Female students (as % of total students) of Nigeria in 2002?
Provide a succinct answer. 6.31. What is the difference between the Female students (as % of total students) in Europe(all income levels) in 1989 and the Female students (as % of total students) in Turkey in 2002?
Keep it short and to the point. 7.35. What is the difference between the Female students (as % of total students) in Indonesia in 1989 and the Female students (as % of total students) in Nigeria in 2002?
Your answer should be very brief. 1.95. What is the difference between the Female students (as % of total students) of Indonesia in 1989 and the Female students (as % of total students) of Turkey in 2002?
Your answer should be very brief. 2.99. What is the difference between the Female students (as % of total students) in Nigeria in 1989 and the Female students (as % of total students) in Turkey in 2002?
Ensure brevity in your answer.  1.96. What is the difference between the Female students (as % of total students) in Europe(all income levels) in 1990 and the Female students (as % of total students) in Indonesia in 1999?
Make the answer very short. 0.67. What is the difference between the Female students (as % of total students) in Europe(all income levels) in 1990 and the Female students (as % of total students) in Nigeria in 1999?
Provide a short and direct response. 2.01. What is the difference between the Female students (as % of total students) of Europe(all income levels) in 1990 and the Female students (as % of total students) of Turkey in 1999?
Your response must be concise. 8.73. What is the difference between the Female students (as % of total students) in Indonesia in 1990 and the Female students (as % of total students) in Nigeria in 1999?
Your answer should be compact. -1.9. What is the difference between the Female students (as % of total students) of Indonesia in 1990 and the Female students (as % of total students) of Turkey in 1999?
Offer a terse response. 4.82. What is the difference between the Female students (as % of total students) in Nigeria in 1990 and the Female students (as % of total students) in Turkey in 1999?
Provide a succinct answer. 2.83. What is the difference between the Female students (as % of total students) in Europe(all income levels) in 1990 and the Female students (as % of total students) in Indonesia in 2000?
Offer a terse response. 0.32. What is the difference between the Female students (as % of total students) of Europe(all income levels) in 1990 and the Female students (as % of total students) of Nigeria in 2000?
Ensure brevity in your answer.  3.9. What is the difference between the Female students (as % of total students) in Europe(all income levels) in 1990 and the Female students (as % of total students) in Turkey in 2000?
Keep it short and to the point. 7.28. What is the difference between the Female students (as % of total students) of Indonesia in 1990 and the Female students (as % of total students) of Nigeria in 2000?
Your answer should be compact. -0.02. What is the difference between the Female students (as % of total students) in Indonesia in 1990 and the Female students (as % of total students) in Turkey in 2000?
Ensure brevity in your answer.  3.37. What is the difference between the Female students (as % of total students) in Nigeria in 1990 and the Female students (as % of total students) in Turkey in 2000?
Make the answer very short. 1.38. What is the difference between the Female students (as % of total students) of Europe(all income levels) in 1990 and the Female students (as % of total students) of Indonesia in 2001?
Provide a succinct answer. -0. What is the difference between the Female students (as % of total students) in Europe(all income levels) in 1990 and the Female students (as % of total students) in Nigeria in 2001?
Offer a very short reply. 4.14. What is the difference between the Female students (as % of total students) in Europe(all income levels) in 1990 and the Female students (as % of total students) in Turkey in 2001?
Your answer should be very brief. 7.27. What is the difference between the Female students (as % of total students) of Indonesia in 1990 and the Female students (as % of total students) of Nigeria in 2001?
Offer a terse response. 0.22. What is the difference between the Female students (as % of total students) in Indonesia in 1990 and the Female students (as % of total students) in Turkey in 2001?
Offer a very short reply. 3.35. What is the difference between the Female students (as % of total students) in Nigeria in 1990 and the Female students (as % of total students) in Turkey in 2001?
Offer a terse response. 1.37. What is the difference between the Female students (as % of total students) of Europe(all income levels) in 1990 and the Female students (as % of total students) of Indonesia in 2002?
Give a very brief answer. -0.2. What is the difference between the Female students (as % of total students) of Europe(all income levels) in 1990 and the Female students (as % of total students) of Nigeria in 2002?
Your answer should be very brief. 6.31. What is the difference between the Female students (as % of total students) of Europe(all income levels) in 1990 and the Female students (as % of total students) of Turkey in 2002?
Your answer should be compact. 7.36. What is the difference between the Female students (as % of total students) in Indonesia in 1990 and the Female students (as % of total students) in Nigeria in 2002?
Offer a very short reply. 2.4. What is the difference between the Female students (as % of total students) of Indonesia in 1990 and the Female students (as % of total students) of Turkey in 2002?
Your answer should be compact. 3.44. What is the difference between the Female students (as % of total students) in Nigeria in 1990 and the Female students (as % of total students) in Turkey in 2002?
Provide a short and direct response. 1.45. What is the difference between the Female students (as % of total students) in Europe(all income levels) in 1999 and the Female students (as % of total students) in Indonesia in 2000?
Provide a succinct answer. 0.12. What is the difference between the Female students (as % of total students) of Europe(all income levels) in 1999 and the Female students (as % of total students) of Nigeria in 2000?
Offer a terse response. 3.7. What is the difference between the Female students (as % of total students) of Europe(all income levels) in 1999 and the Female students (as % of total students) of Turkey in 2000?
Your answer should be compact. 7.09. What is the difference between the Female students (as % of total students) of Indonesia in 1999 and the Female students (as % of total students) of Nigeria in 2000?
Your answer should be compact. 3.23. What is the difference between the Female students (as % of total students) in Indonesia in 1999 and the Female students (as % of total students) in Turkey in 2000?
Offer a very short reply. 6.62. What is the difference between the Female students (as % of total students) in Nigeria in 1999 and the Female students (as % of total students) in Turkey in 2000?
Your response must be concise. 5.27. What is the difference between the Female students (as % of total students) in Europe(all income levels) in 1999 and the Female students (as % of total students) in Indonesia in 2001?
Ensure brevity in your answer.  -0.2. What is the difference between the Female students (as % of total students) in Europe(all income levels) in 1999 and the Female students (as % of total students) in Nigeria in 2001?
Keep it short and to the point. 3.94. What is the difference between the Female students (as % of total students) of Europe(all income levels) in 1999 and the Female students (as % of total students) of Turkey in 2001?
Give a very brief answer. 7.07. What is the difference between the Female students (as % of total students) in Indonesia in 1999 and the Female students (as % of total students) in Nigeria in 2001?
Ensure brevity in your answer.  3.47. What is the difference between the Female students (as % of total students) in Indonesia in 1999 and the Female students (as % of total students) in Turkey in 2001?
Your answer should be very brief. 6.6. What is the difference between the Female students (as % of total students) in Nigeria in 1999 and the Female students (as % of total students) in Turkey in 2001?
Make the answer very short. 5.25. What is the difference between the Female students (as % of total students) of Europe(all income levels) in 1999 and the Female students (as % of total students) of Indonesia in 2002?
Your response must be concise. -0.4. What is the difference between the Female students (as % of total students) in Europe(all income levels) in 1999 and the Female students (as % of total students) in Nigeria in 2002?
Make the answer very short. 6.12. What is the difference between the Female students (as % of total students) in Europe(all income levels) in 1999 and the Female students (as % of total students) in Turkey in 2002?
Give a very brief answer. 7.16. What is the difference between the Female students (as % of total students) in Indonesia in 1999 and the Female students (as % of total students) in Nigeria in 2002?
Offer a terse response. 5.65. What is the difference between the Female students (as % of total students) in Indonesia in 1999 and the Female students (as % of total students) in Turkey in 2002?
Offer a very short reply. 6.69. What is the difference between the Female students (as % of total students) of Nigeria in 1999 and the Female students (as % of total students) of Turkey in 2002?
Offer a very short reply. 5.34. What is the difference between the Female students (as % of total students) in Europe(all income levels) in 2000 and the Female students (as % of total students) in Indonesia in 2001?
Ensure brevity in your answer.  -0.21. What is the difference between the Female students (as % of total students) in Europe(all income levels) in 2000 and the Female students (as % of total students) in Nigeria in 2001?
Keep it short and to the point. 3.94. What is the difference between the Female students (as % of total students) in Europe(all income levels) in 2000 and the Female students (as % of total students) in Turkey in 2001?
Give a very brief answer. 7.07. What is the difference between the Female students (as % of total students) in Indonesia in 2000 and the Female students (as % of total students) in Nigeria in 2001?
Provide a succinct answer. 3.82. What is the difference between the Female students (as % of total students) of Indonesia in 2000 and the Female students (as % of total students) of Turkey in 2001?
Make the answer very short. 6.95. What is the difference between the Female students (as % of total students) in Nigeria in 2000 and the Female students (as % of total students) in Turkey in 2001?
Provide a succinct answer. 3.37. What is the difference between the Female students (as % of total students) in Europe(all income levels) in 2000 and the Female students (as % of total students) in Indonesia in 2002?
Your response must be concise. -0.4. What is the difference between the Female students (as % of total students) in Europe(all income levels) in 2000 and the Female students (as % of total students) in Nigeria in 2002?
Provide a short and direct response. 6.11. What is the difference between the Female students (as % of total students) of Europe(all income levels) in 2000 and the Female students (as % of total students) of Turkey in 2002?
Provide a succinct answer. 7.15. What is the difference between the Female students (as % of total students) of Indonesia in 2000 and the Female students (as % of total students) of Nigeria in 2002?
Your response must be concise. 6. What is the difference between the Female students (as % of total students) in Indonesia in 2000 and the Female students (as % of total students) in Turkey in 2002?
Provide a short and direct response. 7.04. What is the difference between the Female students (as % of total students) in Nigeria in 2000 and the Female students (as % of total students) in Turkey in 2002?
Your answer should be very brief. 3.46. What is the difference between the Female students (as % of total students) in Europe(all income levels) in 2001 and the Female students (as % of total students) in Indonesia in 2002?
Your response must be concise. -0.53. What is the difference between the Female students (as % of total students) in Europe(all income levels) in 2001 and the Female students (as % of total students) in Nigeria in 2002?
Give a very brief answer. 5.98. What is the difference between the Female students (as % of total students) in Europe(all income levels) in 2001 and the Female students (as % of total students) in Turkey in 2002?
Offer a terse response. 7.03. What is the difference between the Female students (as % of total students) of Indonesia in 2001 and the Female students (as % of total students) of Nigeria in 2002?
Ensure brevity in your answer.  6.32. What is the difference between the Female students (as % of total students) of Indonesia in 2001 and the Female students (as % of total students) of Turkey in 2002?
Your response must be concise. 7.36. What is the difference between the Female students (as % of total students) in Nigeria in 2001 and the Female students (as % of total students) in Turkey in 2002?
Your answer should be very brief. 3.22. What is the average Female students (as % of total students) in Europe(all income levels) per year?
Your answer should be compact. 48.66. What is the average Female students (as % of total students) in Indonesia per year?
Give a very brief answer. 45.93. What is the average Female students (as % of total students) of Nigeria per year?
Provide a short and direct response. 39.94. What is the average Female students (as % of total students) of Turkey per year?
Provide a succinct answer. 38.49. In the year 1983, what is the difference between the Female students (as % of total students) of Europe(all income levels) and Female students (as % of total students) of Indonesia?
Provide a short and direct response. 6.96. In the year 1983, what is the difference between the Female students (as % of total students) of Europe(all income levels) and Female students (as % of total students) of Nigeria?
Your answer should be compact. 19.95. In the year 1983, what is the difference between the Female students (as % of total students) in Europe(all income levels) and Female students (as % of total students) in Turkey?
Give a very brief answer. 14.04. In the year 1983, what is the difference between the Female students (as % of total students) of Indonesia and Female students (as % of total students) of Nigeria?
Make the answer very short. 12.99. In the year 1983, what is the difference between the Female students (as % of total students) in Indonesia and Female students (as % of total students) in Turkey?
Offer a terse response. 7.08. In the year 1983, what is the difference between the Female students (as % of total students) of Nigeria and Female students (as % of total students) of Turkey?
Your response must be concise. -5.91. In the year 1984, what is the difference between the Female students (as % of total students) of Europe(all income levels) and Female students (as % of total students) of Indonesia?
Your response must be concise. 6.95. In the year 1984, what is the difference between the Female students (as % of total students) of Europe(all income levels) and Female students (as % of total students) of Nigeria?
Offer a very short reply. 23.28. In the year 1984, what is the difference between the Female students (as % of total students) in Europe(all income levels) and Female students (as % of total students) in Turkey?
Ensure brevity in your answer.  13.73. In the year 1984, what is the difference between the Female students (as % of total students) in Indonesia and Female students (as % of total students) in Nigeria?
Your answer should be very brief. 16.33. In the year 1984, what is the difference between the Female students (as % of total students) of Indonesia and Female students (as % of total students) of Turkey?
Give a very brief answer. 6.78. In the year 1984, what is the difference between the Female students (as % of total students) of Nigeria and Female students (as % of total students) of Turkey?
Your response must be concise. -9.55. In the year 1989, what is the difference between the Female students (as % of total students) of Europe(all income levels) and Female students (as % of total students) of Indonesia?
Keep it short and to the point. 4.36. In the year 1989, what is the difference between the Female students (as % of total students) of Europe(all income levels) and Female students (as % of total students) of Nigeria?
Offer a very short reply. 5.39. In the year 1989, what is the difference between the Female students (as % of total students) of Europe(all income levels) and Female students (as % of total students) of Turkey?
Make the answer very short. 12.27. In the year 1989, what is the difference between the Female students (as % of total students) of Indonesia and Female students (as % of total students) of Nigeria?
Give a very brief answer. 1.03. In the year 1989, what is the difference between the Female students (as % of total students) in Indonesia and Female students (as % of total students) in Turkey?
Keep it short and to the point. 7.91. In the year 1989, what is the difference between the Female students (as % of total students) of Nigeria and Female students (as % of total students) of Turkey?
Give a very brief answer. 6.88. In the year 1990, what is the difference between the Female students (as % of total students) in Europe(all income levels) and Female students (as % of total students) in Indonesia?
Ensure brevity in your answer.  3.91. In the year 1990, what is the difference between the Female students (as % of total students) of Europe(all income levels) and Female students (as % of total students) of Nigeria?
Offer a terse response. 5.9. In the year 1990, what is the difference between the Female students (as % of total students) of Europe(all income levels) and Female students (as % of total students) of Turkey?
Keep it short and to the point. 11.79. In the year 1990, what is the difference between the Female students (as % of total students) in Indonesia and Female students (as % of total students) in Nigeria?
Ensure brevity in your answer.  1.99. In the year 1990, what is the difference between the Female students (as % of total students) of Indonesia and Female students (as % of total students) of Turkey?
Keep it short and to the point. 7.87. In the year 1990, what is the difference between the Female students (as % of total students) in Nigeria and Female students (as % of total students) in Turkey?
Provide a succinct answer. 5.88. In the year 1999, what is the difference between the Female students (as % of total students) of Europe(all income levels) and Female students (as % of total students) of Indonesia?
Keep it short and to the point. 0.47. In the year 1999, what is the difference between the Female students (as % of total students) in Europe(all income levels) and Female students (as % of total students) in Nigeria?
Make the answer very short. 1.82. In the year 1999, what is the difference between the Female students (as % of total students) of Europe(all income levels) and Female students (as % of total students) of Turkey?
Keep it short and to the point. 8.54. In the year 1999, what is the difference between the Female students (as % of total students) of Indonesia and Female students (as % of total students) of Nigeria?
Provide a succinct answer. 1.35. In the year 1999, what is the difference between the Female students (as % of total students) of Indonesia and Female students (as % of total students) of Turkey?
Your answer should be very brief. 8.07. In the year 1999, what is the difference between the Female students (as % of total students) of Nigeria and Female students (as % of total students) of Turkey?
Offer a terse response. 6.72. In the year 2000, what is the difference between the Female students (as % of total students) in Europe(all income levels) and Female students (as % of total students) in Indonesia?
Offer a terse response. 0.12. In the year 2000, what is the difference between the Female students (as % of total students) in Europe(all income levels) and Female students (as % of total students) in Nigeria?
Provide a succinct answer. 3.69. In the year 2000, what is the difference between the Female students (as % of total students) in Europe(all income levels) and Female students (as % of total students) in Turkey?
Your answer should be very brief. 7.08. In the year 2000, what is the difference between the Female students (as % of total students) in Indonesia and Female students (as % of total students) in Nigeria?
Provide a succinct answer. 3.58. In the year 2000, what is the difference between the Female students (as % of total students) in Indonesia and Female students (as % of total students) in Turkey?
Offer a terse response. 6.97. In the year 2000, what is the difference between the Female students (as % of total students) in Nigeria and Female students (as % of total students) in Turkey?
Offer a terse response. 3.39. In the year 2001, what is the difference between the Female students (as % of total students) of Europe(all income levels) and Female students (as % of total students) of Indonesia?
Provide a short and direct response. -0.33. In the year 2001, what is the difference between the Female students (as % of total students) of Europe(all income levels) and Female students (as % of total students) of Nigeria?
Provide a short and direct response. 3.81. In the year 2001, what is the difference between the Female students (as % of total students) in Europe(all income levels) and Female students (as % of total students) in Turkey?
Offer a terse response. 6.94. In the year 2001, what is the difference between the Female students (as % of total students) in Indonesia and Female students (as % of total students) in Nigeria?
Your response must be concise. 4.14. In the year 2001, what is the difference between the Female students (as % of total students) of Indonesia and Female students (as % of total students) of Turkey?
Keep it short and to the point. 7.27. In the year 2001, what is the difference between the Female students (as % of total students) in Nigeria and Female students (as % of total students) in Turkey?
Your response must be concise. 3.13. In the year 2002, what is the difference between the Female students (as % of total students) of Europe(all income levels) and Female students (as % of total students) of Indonesia?
Provide a short and direct response. -0.61. In the year 2002, what is the difference between the Female students (as % of total students) of Europe(all income levels) and Female students (as % of total students) of Nigeria?
Ensure brevity in your answer.  5.9. In the year 2002, what is the difference between the Female students (as % of total students) of Europe(all income levels) and Female students (as % of total students) of Turkey?
Your answer should be compact. 6.95. In the year 2002, what is the difference between the Female students (as % of total students) in Indonesia and Female students (as % of total students) in Nigeria?
Your answer should be compact. 6.52. In the year 2002, what is the difference between the Female students (as % of total students) of Indonesia and Female students (as % of total students) of Turkey?
Your answer should be very brief. 7.56. In the year 2002, what is the difference between the Female students (as % of total students) of Nigeria and Female students (as % of total students) of Turkey?
Provide a succinct answer. 1.04. What is the ratio of the Female students (as % of total students) of Indonesia in 1983 to that in 1984?
Keep it short and to the point. 1. What is the ratio of the Female students (as % of total students) in Nigeria in 1983 to that in 1984?
Your answer should be very brief. 1.13. What is the ratio of the Female students (as % of total students) of Turkey in 1983 to that in 1984?
Provide a succinct answer. 0.99. What is the ratio of the Female students (as % of total students) of Indonesia in 1983 to that in 1989?
Offer a terse response. 0.94. What is the ratio of the Female students (as % of total students) in Nigeria in 1983 to that in 1989?
Ensure brevity in your answer.  0.67. What is the ratio of the Female students (as % of total students) of Turkey in 1983 to that in 1989?
Your response must be concise. 0.95. What is the ratio of the Female students (as % of total students) in Europe(all income levels) in 1983 to that in 1990?
Your answer should be compact. 1. What is the ratio of the Female students (as % of total students) in Indonesia in 1983 to that in 1990?
Provide a short and direct response. 0.93. What is the ratio of the Female students (as % of total students) in Nigeria in 1983 to that in 1990?
Offer a very short reply. 0.67. What is the ratio of the Female students (as % of total students) in Turkey in 1983 to that in 1990?
Make the answer very short. 0.94. What is the ratio of the Female students (as % of total students) in Europe(all income levels) in 1983 to that in 1999?
Provide a short and direct response. 1.01. What is the ratio of the Female students (as % of total students) of Indonesia in 1983 to that in 1999?
Provide a short and direct response. 0.87. What is the ratio of the Female students (as % of total students) of Nigeria in 1983 to that in 1999?
Your answer should be compact. 0.62. What is the ratio of the Female students (as % of total students) in Turkey in 1983 to that in 1999?
Make the answer very short. 0.87. What is the ratio of the Female students (as % of total students) in Europe(all income levels) in 1983 to that in 2000?
Your answer should be very brief. 1.01. What is the ratio of the Female students (as % of total students) of Indonesia in 1983 to that in 2000?
Offer a terse response. 0.86. What is the ratio of the Female students (as % of total students) in Nigeria in 1983 to that in 2000?
Make the answer very short. 0.64. What is the ratio of the Female students (as % of total students) in Turkey in 1983 to that in 2000?
Make the answer very short. 0.84. What is the ratio of the Female students (as % of total students) of Europe(all income levels) in 1983 to that in 2001?
Offer a very short reply. 1.01. What is the ratio of the Female students (as % of total students) in Indonesia in 1983 to that in 2001?
Ensure brevity in your answer.  0.86. What is the ratio of the Female students (as % of total students) of Nigeria in 1983 to that in 2001?
Offer a terse response. 0.65. What is the ratio of the Female students (as % of total students) in Turkey in 1983 to that in 2001?
Give a very brief answer. 0.84. What is the ratio of the Female students (as % of total students) in Europe(all income levels) in 1983 to that in 2002?
Provide a succinct answer. 1.01. What is the ratio of the Female students (as % of total students) in Indonesia in 1983 to that in 2002?
Provide a short and direct response. 0.86. What is the ratio of the Female students (as % of total students) in Nigeria in 1983 to that in 2002?
Your answer should be compact. 0.68. What is the ratio of the Female students (as % of total students) in Turkey in 1983 to that in 2002?
Provide a short and direct response. 0.84. What is the ratio of the Female students (as % of total students) of Europe(all income levels) in 1984 to that in 1989?
Make the answer very short. 1. What is the ratio of the Female students (as % of total students) in Indonesia in 1984 to that in 1989?
Your response must be concise. 0.94. What is the ratio of the Female students (as % of total students) of Nigeria in 1984 to that in 1989?
Give a very brief answer. 0.59. What is the ratio of the Female students (as % of total students) in Turkey in 1984 to that in 1989?
Your answer should be compact. 0.96. What is the ratio of the Female students (as % of total students) in Indonesia in 1984 to that in 1990?
Your answer should be very brief. 0.93. What is the ratio of the Female students (as % of total students) in Nigeria in 1984 to that in 1990?
Your answer should be compact. 0.6. What is the ratio of the Female students (as % of total students) in Turkey in 1984 to that in 1990?
Ensure brevity in your answer.  0.95. What is the ratio of the Female students (as % of total students) in Europe(all income levels) in 1984 to that in 1999?
Keep it short and to the point. 1.01. What is the ratio of the Female students (as % of total students) of Indonesia in 1984 to that in 1999?
Give a very brief answer. 0.87. What is the ratio of the Female students (as % of total students) in Nigeria in 1984 to that in 1999?
Give a very brief answer. 0.55. What is the ratio of the Female students (as % of total students) in Turkey in 1984 to that in 1999?
Your response must be concise. 0.88. What is the ratio of the Female students (as % of total students) of Indonesia in 1984 to that in 2000?
Your answer should be very brief. 0.86. What is the ratio of the Female students (as % of total students) of Nigeria in 1984 to that in 2000?
Provide a succinct answer. 0.57. What is the ratio of the Female students (as % of total students) of Turkey in 1984 to that in 2000?
Keep it short and to the point. 0.85. What is the ratio of the Female students (as % of total students) in Europe(all income levels) in 1984 to that in 2001?
Keep it short and to the point. 1.01. What is the ratio of the Female students (as % of total students) in Indonesia in 1984 to that in 2001?
Your response must be concise. 0.86. What is the ratio of the Female students (as % of total students) in Nigeria in 1984 to that in 2001?
Your response must be concise. 0.57. What is the ratio of the Female students (as % of total students) in Turkey in 1984 to that in 2001?
Provide a succinct answer. 0.85. What is the ratio of the Female students (as % of total students) of Europe(all income levels) in 1984 to that in 2002?
Provide a succinct answer. 1.01. What is the ratio of the Female students (as % of total students) in Indonesia in 1984 to that in 2002?
Give a very brief answer. 0.86. What is the ratio of the Female students (as % of total students) of Nigeria in 1984 to that in 2002?
Offer a very short reply. 0.6. What is the ratio of the Female students (as % of total students) in Turkey in 1984 to that in 2002?
Your answer should be compact. 0.85. What is the ratio of the Female students (as % of total students) in Europe(all income levels) in 1989 to that in 1990?
Your response must be concise. 1. What is the ratio of the Female students (as % of total students) in Indonesia in 1989 to that in 1990?
Provide a short and direct response. 0.99. What is the ratio of the Female students (as % of total students) of Nigeria in 1989 to that in 1990?
Make the answer very short. 1.01. What is the ratio of the Female students (as % of total students) in Turkey in 1989 to that in 1990?
Provide a short and direct response. 0.99. What is the ratio of the Female students (as % of total students) of Europe(all income levels) in 1989 to that in 1999?
Your response must be concise. 1. What is the ratio of the Female students (as % of total students) of Indonesia in 1989 to that in 1999?
Ensure brevity in your answer.  0.92. What is the ratio of the Female students (as % of total students) of Nigeria in 1989 to that in 1999?
Provide a short and direct response. 0.93. What is the ratio of the Female students (as % of total students) in Turkey in 1989 to that in 1999?
Provide a succinct answer. 0.91. What is the ratio of the Female students (as % of total students) of Europe(all income levels) in 1989 to that in 2000?
Offer a very short reply. 1. What is the ratio of the Female students (as % of total students) of Indonesia in 1989 to that in 2000?
Give a very brief answer. 0.92. What is the ratio of the Female students (as % of total students) of Nigeria in 1989 to that in 2000?
Your response must be concise. 0.97. What is the ratio of the Female students (as % of total students) of Turkey in 1989 to that in 2000?
Give a very brief answer. 0.88. What is the ratio of the Female students (as % of total students) of Indonesia in 1989 to that in 2001?
Your response must be concise. 0.91. What is the ratio of the Female students (as % of total students) of Nigeria in 1989 to that in 2001?
Provide a succinct answer. 0.97. What is the ratio of the Female students (as % of total students) of Turkey in 1989 to that in 2001?
Offer a terse response. 0.88. What is the ratio of the Female students (as % of total students) of Europe(all income levels) in 1989 to that in 2002?
Ensure brevity in your answer.  1.01. What is the ratio of the Female students (as % of total students) in Indonesia in 1989 to that in 2002?
Your answer should be very brief. 0.91. What is the ratio of the Female students (as % of total students) in Nigeria in 1989 to that in 2002?
Make the answer very short. 1.02. What is the ratio of the Female students (as % of total students) in Turkey in 1989 to that in 2002?
Provide a succinct answer. 0.88. What is the ratio of the Female students (as % of total students) of Indonesia in 1990 to that in 1999?
Offer a terse response. 0.93. What is the ratio of the Female students (as % of total students) in Nigeria in 1990 to that in 1999?
Provide a short and direct response. 0.92. What is the ratio of the Female students (as % of total students) of Turkey in 1990 to that in 1999?
Ensure brevity in your answer.  0.92. What is the ratio of the Female students (as % of total students) of Indonesia in 1990 to that in 2000?
Ensure brevity in your answer.  0.93. What is the ratio of the Female students (as % of total students) in Nigeria in 1990 to that in 2000?
Your answer should be very brief. 0.96. What is the ratio of the Female students (as % of total students) of Turkey in 1990 to that in 2000?
Give a very brief answer. 0.89. What is the ratio of the Female students (as % of total students) in Europe(all income levels) in 1990 to that in 2001?
Ensure brevity in your answer.  1.01. What is the ratio of the Female students (as % of total students) in Indonesia in 1990 to that in 2001?
Keep it short and to the point. 0.92. What is the ratio of the Female students (as % of total students) of Nigeria in 1990 to that in 2001?
Your answer should be compact. 0.96. What is the ratio of the Female students (as % of total students) of Turkey in 1990 to that in 2001?
Give a very brief answer. 0.89. What is the ratio of the Female students (as % of total students) of Europe(all income levels) in 1990 to that in 2002?
Provide a succinct answer. 1.01. What is the ratio of the Female students (as % of total students) in Indonesia in 1990 to that in 2002?
Offer a very short reply. 0.92. What is the ratio of the Female students (as % of total students) of Nigeria in 1990 to that in 2002?
Keep it short and to the point. 1.01. What is the ratio of the Female students (as % of total students) of Turkey in 1990 to that in 2002?
Give a very brief answer. 0.89. What is the ratio of the Female students (as % of total students) of Indonesia in 1999 to that in 2000?
Offer a terse response. 0.99. What is the ratio of the Female students (as % of total students) of Nigeria in 1999 to that in 2000?
Keep it short and to the point. 1.04. What is the ratio of the Female students (as % of total students) of Indonesia in 1999 to that in 2001?
Your answer should be compact. 0.99. What is the ratio of the Female students (as % of total students) of Nigeria in 1999 to that in 2001?
Offer a very short reply. 1.05. What is the ratio of the Female students (as % of total students) in Turkey in 1999 to that in 2001?
Offer a terse response. 0.96. What is the ratio of the Female students (as % of total students) of Europe(all income levels) in 1999 to that in 2002?
Offer a terse response. 1. What is the ratio of the Female students (as % of total students) of Indonesia in 1999 to that in 2002?
Offer a very short reply. 0.98. What is the ratio of the Female students (as % of total students) of Nigeria in 1999 to that in 2002?
Provide a short and direct response. 1.1. What is the ratio of the Female students (as % of total students) in Turkey in 1999 to that in 2002?
Your answer should be compact. 0.97. What is the ratio of the Female students (as % of total students) in Nigeria in 2000 to that in 2001?
Keep it short and to the point. 1.01. What is the ratio of the Female students (as % of total students) of Turkey in 2000 to that in 2001?
Offer a terse response. 1. What is the ratio of the Female students (as % of total students) of Nigeria in 2000 to that in 2002?
Your response must be concise. 1.06. What is the ratio of the Female students (as % of total students) of Indonesia in 2001 to that in 2002?
Provide a succinct answer. 1. What is the ratio of the Female students (as % of total students) in Nigeria in 2001 to that in 2002?
Provide a short and direct response. 1.05. What is the difference between the highest and the second highest Female students (as % of total students) in Europe(all income levels)?
Your answer should be very brief. 0.03. What is the difference between the highest and the second highest Female students (as % of total students) of Indonesia?
Make the answer very short. 0.2. What is the difference between the highest and the second highest Female students (as % of total students) of Nigeria?
Offer a very short reply. 1.88. What is the difference between the highest and the second highest Female students (as % of total students) in Turkey?
Provide a succinct answer. 0.02. What is the difference between the highest and the lowest Female students (as % of total students) of Europe(all income levels)?
Give a very brief answer. 0.49. What is the difference between the highest and the lowest Female students (as % of total students) of Indonesia?
Your answer should be compact. 7.1. What is the difference between the highest and the lowest Female students (as % of total students) of Nigeria?
Your answer should be very brief. 21.21. What is the difference between the highest and the lowest Female students (as % of total students) of Turkey?
Your answer should be compact. 6.69. 